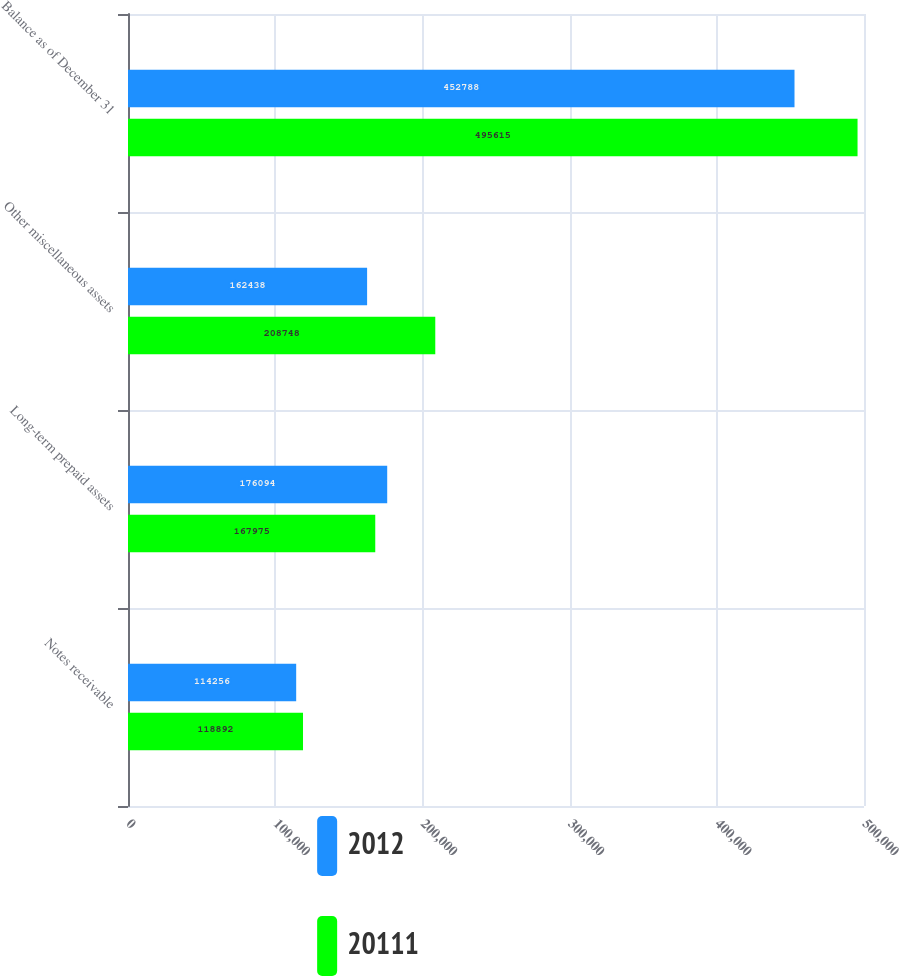Convert chart to OTSL. <chart><loc_0><loc_0><loc_500><loc_500><stacked_bar_chart><ecel><fcel>Notes receivable<fcel>Long-term prepaid assets<fcel>Other miscellaneous assets<fcel>Balance as of December 31<nl><fcel>2012<fcel>114256<fcel>176094<fcel>162438<fcel>452788<nl><fcel>20111<fcel>118892<fcel>167975<fcel>208748<fcel>495615<nl></chart> 